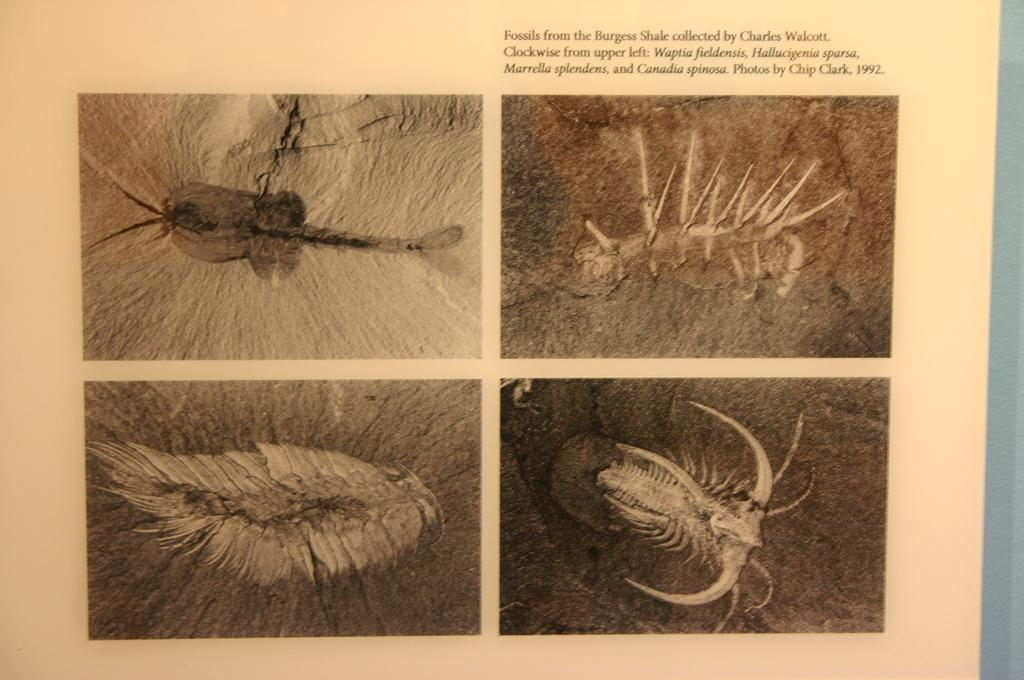What is present in the image that contains information or illustrations? There is a paper in the image. What type of images can be seen on the paper? The paper contains pictures of fossils. Is there any text on the paper? Yes, there is text on the paper. Can you see a kitten supporting a ship in the image? No, there is no kitten or ship present in the image. 